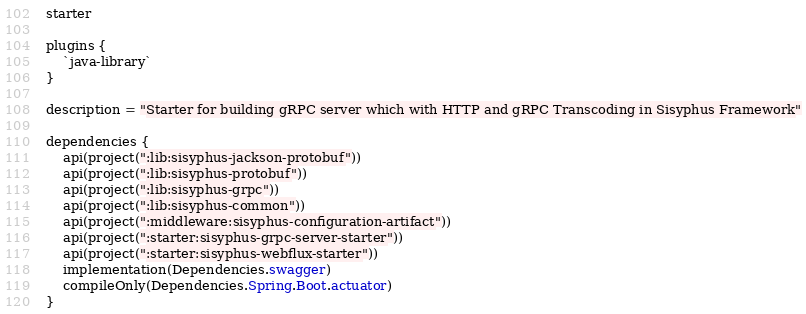Convert code to text. <code><loc_0><loc_0><loc_500><loc_500><_Kotlin_>starter

plugins {
    `java-library`
}

description = "Starter for building gRPC server which with HTTP and gRPC Transcoding in Sisyphus Framework"

dependencies {
    api(project(":lib:sisyphus-jackson-protobuf"))
    api(project(":lib:sisyphus-protobuf"))
    api(project(":lib:sisyphus-grpc"))
    api(project(":lib:sisyphus-common"))
    api(project(":middleware:sisyphus-configuration-artifact"))
    api(project(":starter:sisyphus-grpc-server-starter"))
    api(project(":starter:sisyphus-webflux-starter"))
    implementation(Dependencies.swagger)
    compileOnly(Dependencies.Spring.Boot.actuator)
}
</code> 